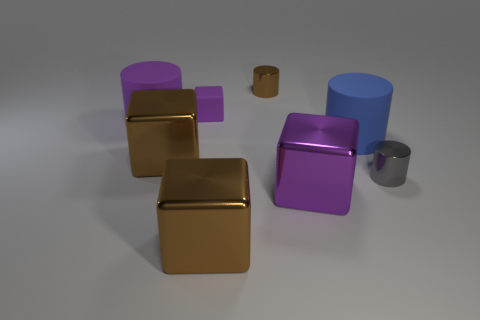Subtract all tiny blocks. How many blocks are left? 3 Subtract all green cylinders. How many purple cubes are left? 2 Subtract all blue cylinders. How many cylinders are left? 3 Subtract 2 cylinders. How many cylinders are left? 2 Add 2 small blue matte balls. How many objects exist? 10 Subtract all yellow cylinders. Subtract all brown balls. How many cylinders are left? 4 Add 6 yellow shiny cylinders. How many yellow shiny cylinders exist? 6 Subtract 0 green spheres. How many objects are left? 8 Subtract all big blocks. Subtract all blue cylinders. How many objects are left? 4 Add 6 brown things. How many brown things are left? 9 